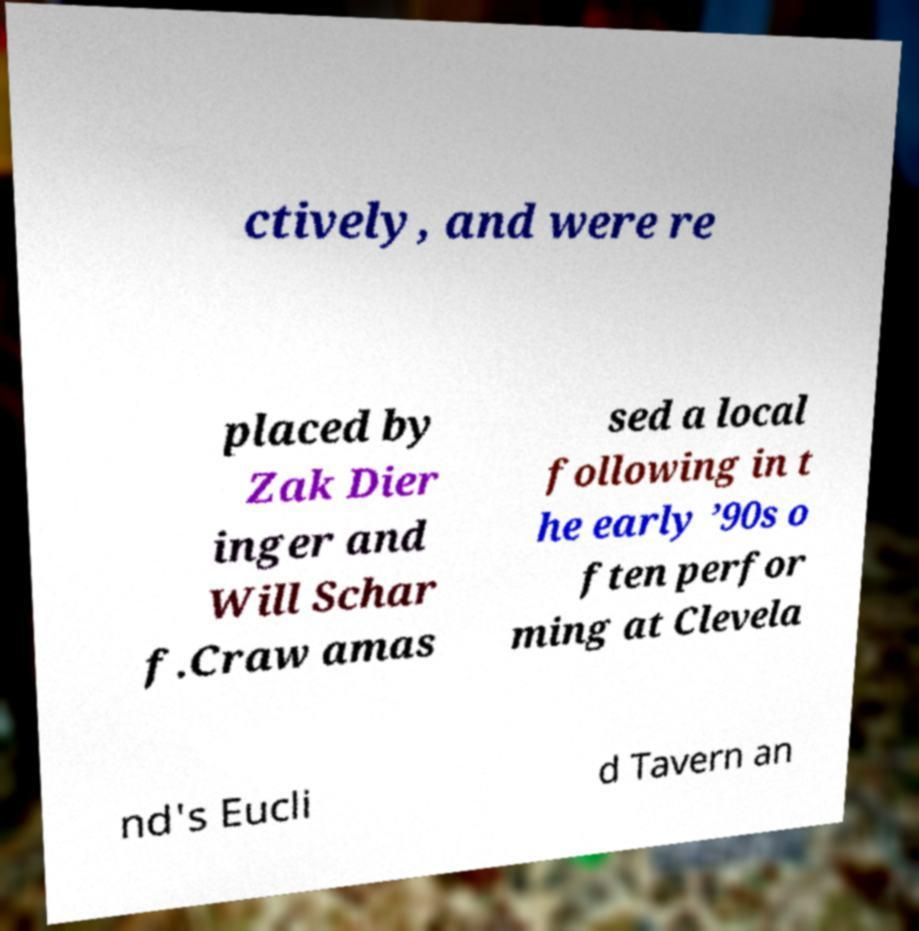Can you read and provide the text displayed in the image?This photo seems to have some interesting text. Can you extract and type it out for me? ctively, and were re placed by Zak Dier inger and Will Schar f.Craw amas sed a local following in t he early ’90s o ften perfor ming at Clevela nd's Eucli d Tavern an 